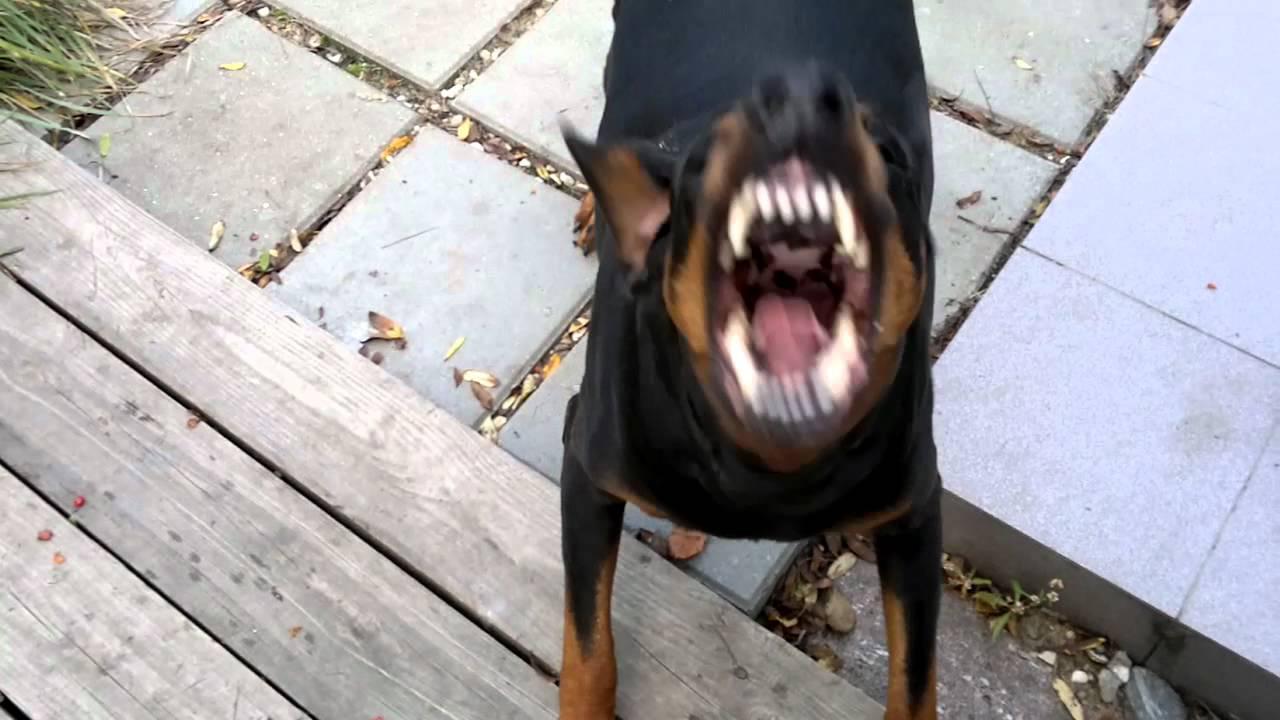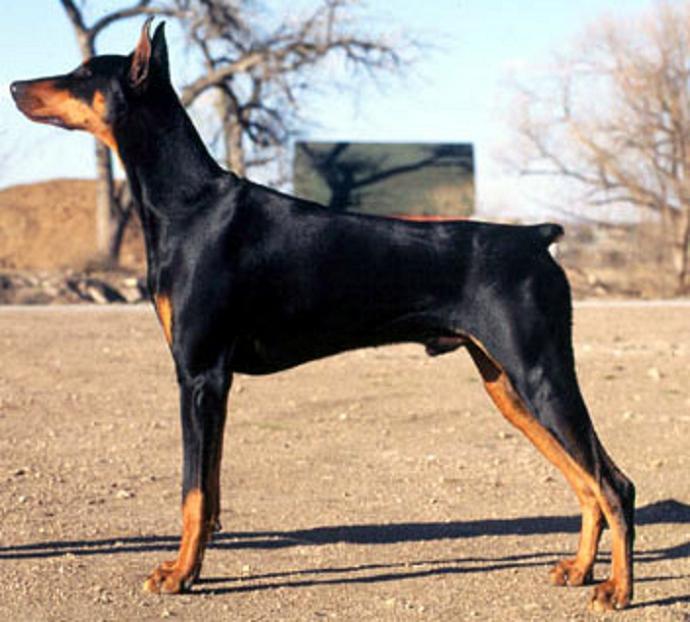The first image is the image on the left, the second image is the image on the right. Assess this claim about the two images: "The left image contains a doberman with its mouth open wide and its fangs bared, and the right image contains at least one doberman with its body and gaze facing left.". Correct or not? Answer yes or no. Yes. The first image is the image on the left, the second image is the image on the right. Evaluate the accuracy of this statement regarding the images: "A doberman has its mouth open.". Is it true? Answer yes or no. Yes. 